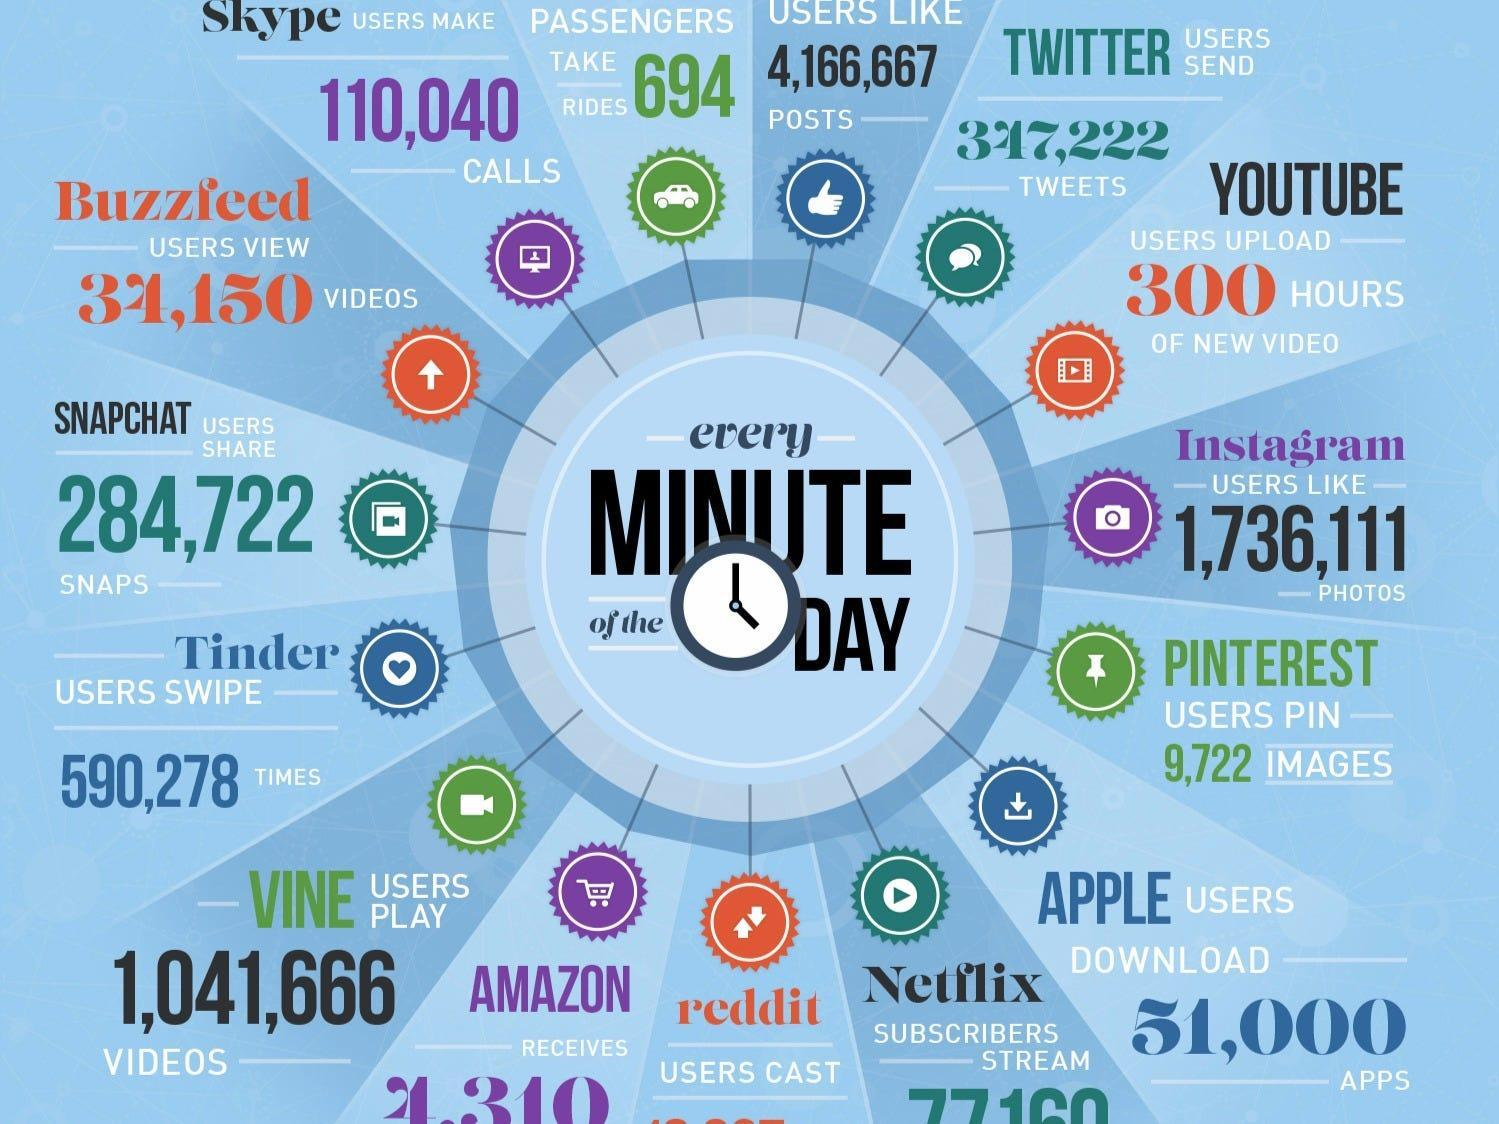Which apps are denoted in orange color?
Answer the question with a short phrase. Buzzfeed, Youtube, Reddit What is the number of users give likes to articles  110,040, 1,736,111, or 4,166,667? 4,166,667 Which apps are denoted in violet color? Skype, Instagram, Amazon 